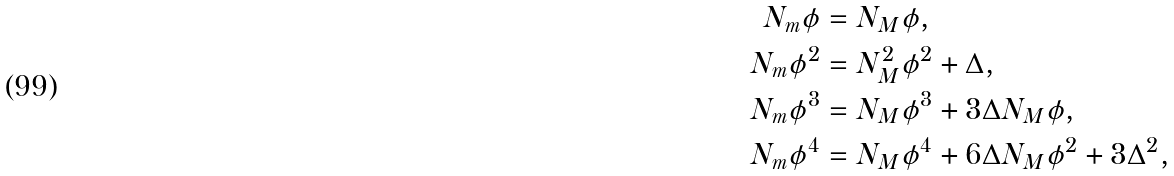<formula> <loc_0><loc_0><loc_500><loc_500>N _ { m } \phi & = N _ { M } \phi , \\ N _ { m } \phi ^ { 2 } & = N _ { M } ^ { 2 } \phi ^ { 2 } + \Delta , \\ N _ { m } \phi ^ { 3 } & = N _ { M } \phi ^ { 3 } + 3 \Delta N _ { M } \phi , \\ N _ { m } \phi ^ { 4 } & = N _ { M } \phi ^ { 4 } + 6 \Delta N _ { M } \phi ^ { 2 } + 3 \Delta ^ { 2 } ,</formula> 